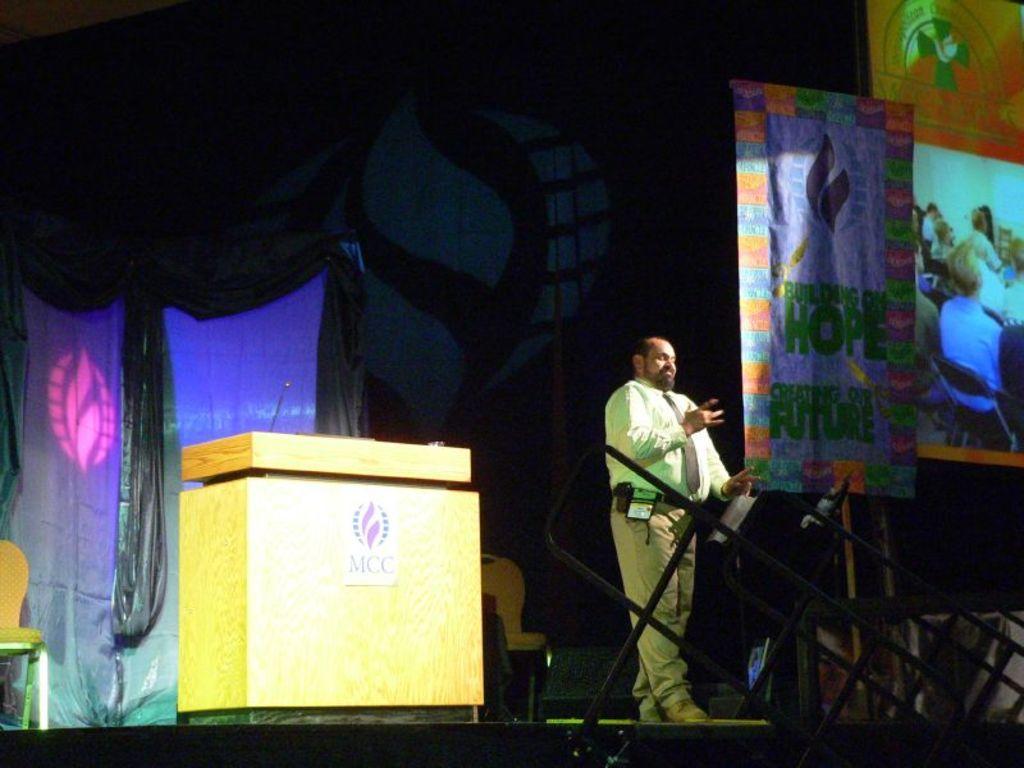Could you give a brief overview of what you see in this image? In the image we can see there is a person standing on the stage and there is a podium behind the person. There is a mic kept on the podium and there is a chair kept on the stage. There are banners and projector screen at the back. There are iron poles. 